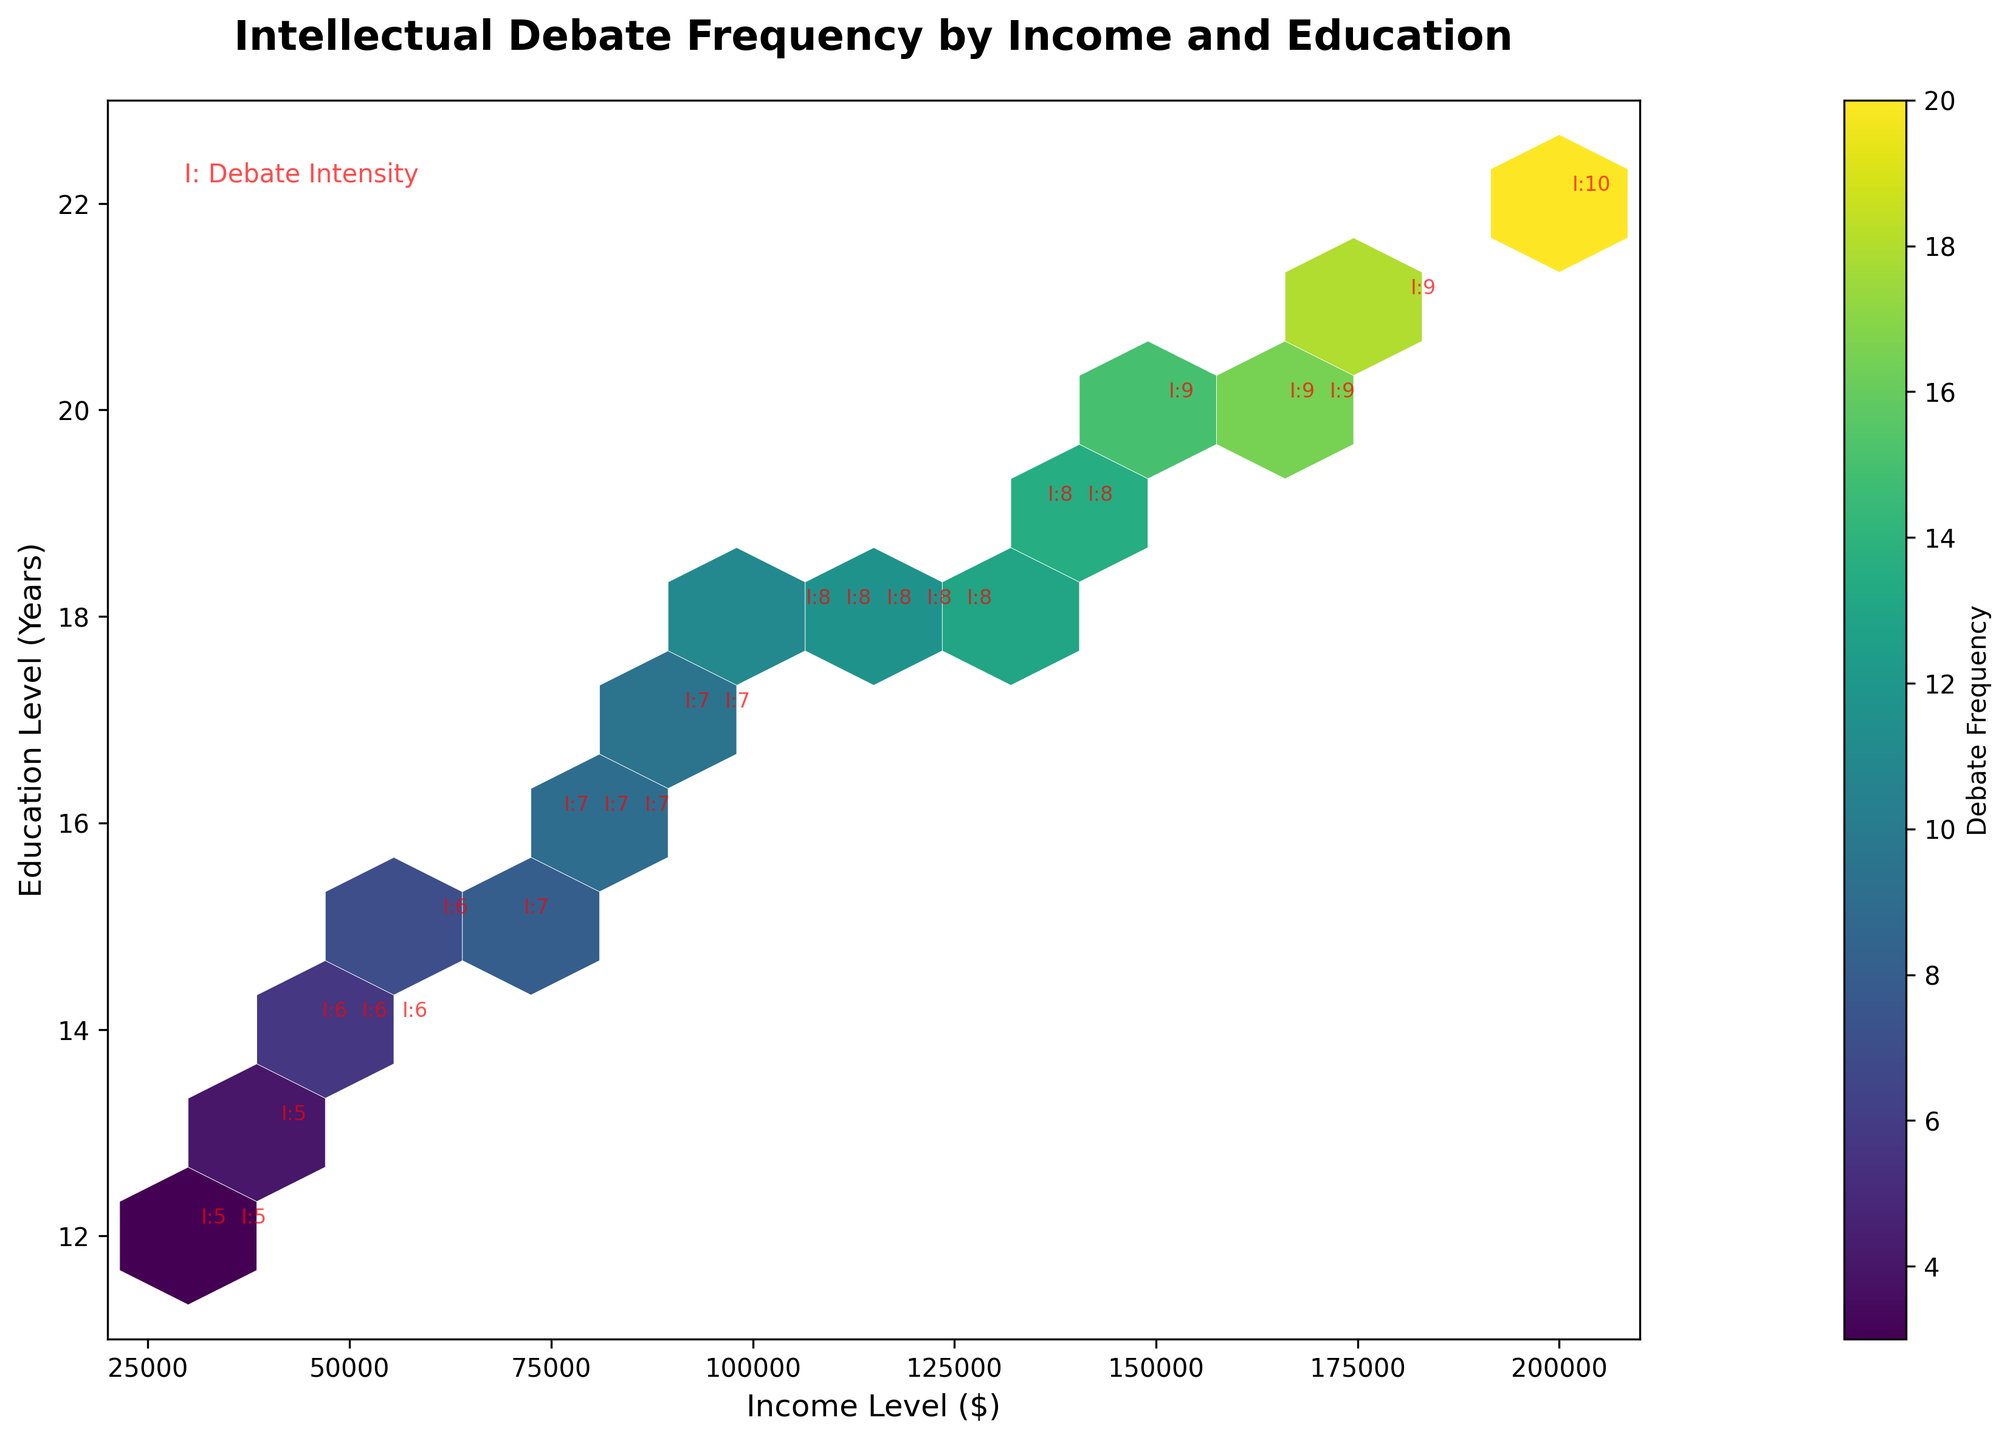What's the title of the figure? The title of the figure is usually located at the top and is in bold font.
Answer: Intellectual Debate Frequency by Income and Education What are the x and y axes in the figure? The x-axis represents the 'Income Level ($)', and the y-axis shows the 'Education Level (Years)'.
Answer: Income Level ($), Education Level (Years) What color represents the highest debate frequency in the hexbin plot? The color map used is 'viridis', where darker shades usually represent higher frequencies.
Answer: Darker shades Look at the point with annotation "I:7" at an income level of 90K. How many years of education does it represent? Locate the annotation "I:7", which refers to Debate Intensity = 7 and find the corresponding y-axis value.
Answer: 17 years Which education level has the highest debate intensity annotated, and what is that intensity? The highest annotated intensity is "I:10" at the income level of 200K. The corresponding education level should be checked.
Answer: 22 years, 10 How does debate frequency change with income levels between 50K and 150K? To understand this, observe the colors of the hexagons between these income levels. Lighter colors indicate lower frequencies while darker indicate higher.
Answer: Debate frequency increases Compare the debate frequency for someone with 16 years of education and 75K income level versus 16 years of education and 80K income level. We look at the hexagons' colors near these coordinates and compare their darkness for the same education level, showing the frequency represented.
Answer: Higher at 80K Are there more high-frequency debates at higher educational levels or lower educational levels? Based on the color saturation, where darker colors are typically located can be observed and inferred.
Answer: Higher educational levels What's an interesting trend you notice about debate intensity annotations across various socioeconomic groups? Annotations with higher debate intensity tend to cluster around higher income and educational levels.
Answer: Higher debate intensity with higher income and education What is the lowest income level represented in the figure, and what is the corresponding debate frequency? Check the x-axis for the minimum income level and then observe the hexagon's color at the corresponding coordinate.
Answer: 30K, 3 